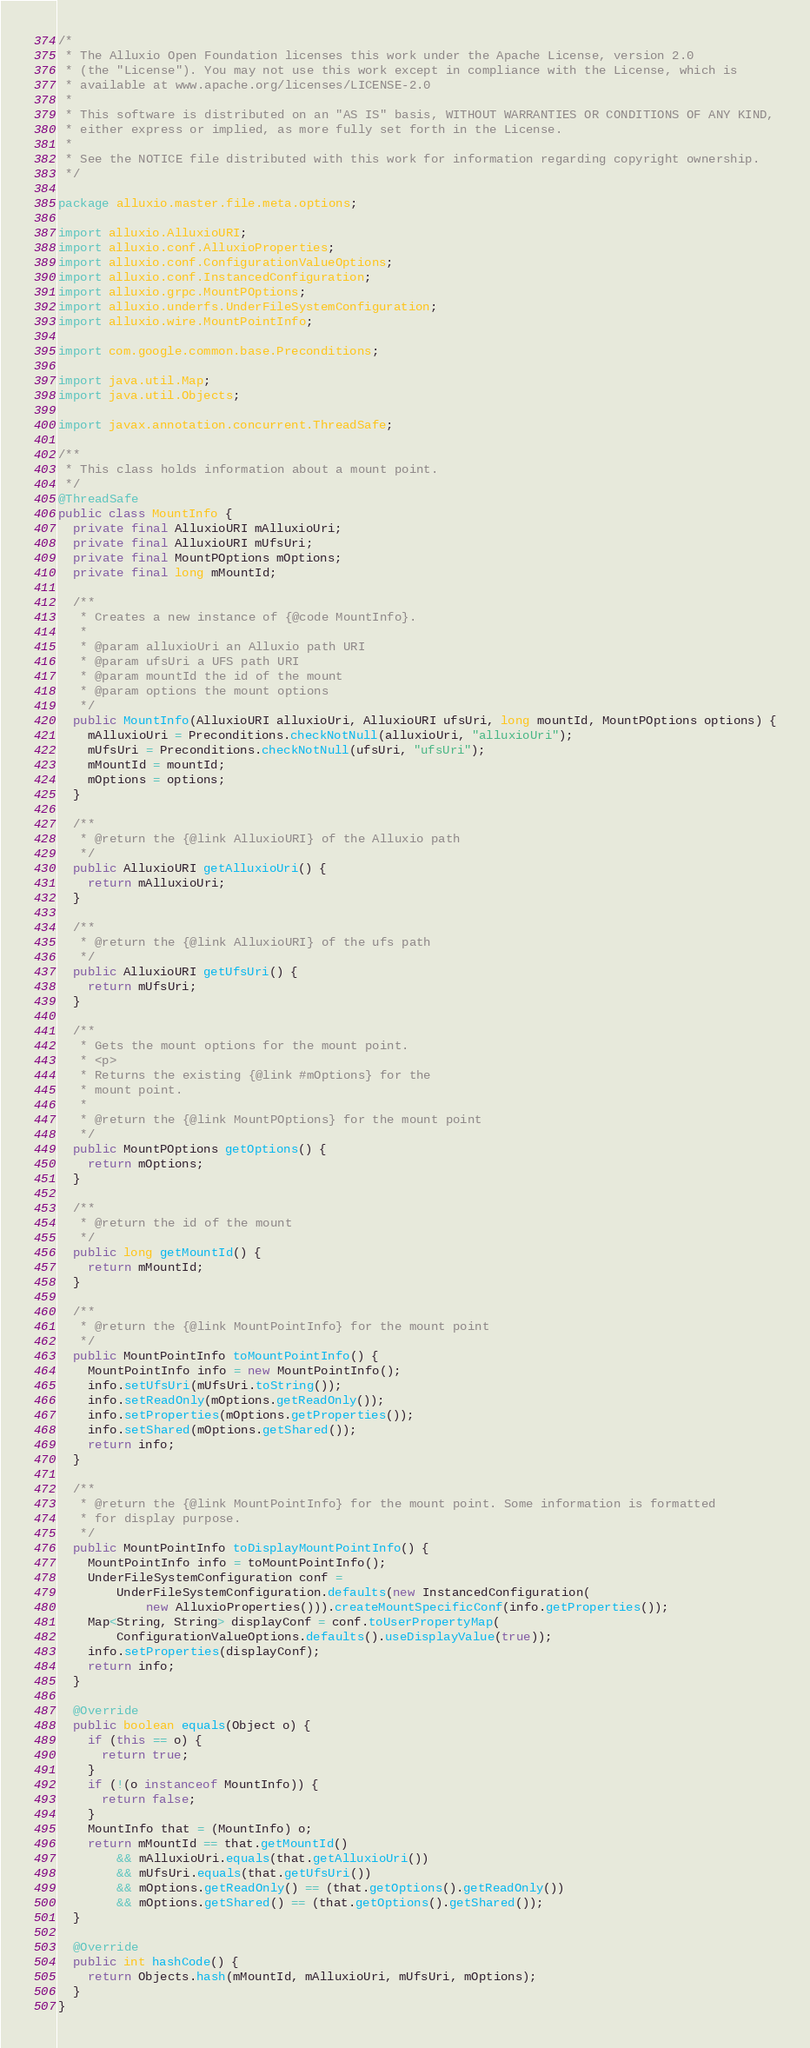<code> <loc_0><loc_0><loc_500><loc_500><_Java_>/*
 * The Alluxio Open Foundation licenses this work under the Apache License, version 2.0
 * (the "License"). You may not use this work except in compliance with the License, which is
 * available at www.apache.org/licenses/LICENSE-2.0
 *
 * This software is distributed on an "AS IS" basis, WITHOUT WARRANTIES OR CONDITIONS OF ANY KIND,
 * either express or implied, as more fully set forth in the License.
 *
 * See the NOTICE file distributed with this work for information regarding copyright ownership.
 */

package alluxio.master.file.meta.options;

import alluxio.AlluxioURI;
import alluxio.conf.AlluxioProperties;
import alluxio.conf.ConfigurationValueOptions;
import alluxio.conf.InstancedConfiguration;
import alluxio.grpc.MountPOptions;
import alluxio.underfs.UnderFileSystemConfiguration;
import alluxio.wire.MountPointInfo;

import com.google.common.base.Preconditions;

import java.util.Map;
import java.util.Objects;

import javax.annotation.concurrent.ThreadSafe;

/**
 * This class holds information about a mount point.
 */
@ThreadSafe
public class MountInfo {
  private final AlluxioURI mAlluxioUri;
  private final AlluxioURI mUfsUri;
  private final MountPOptions mOptions;
  private final long mMountId;

  /**
   * Creates a new instance of {@code MountInfo}.
   *
   * @param alluxioUri an Alluxio path URI
   * @param ufsUri a UFS path URI
   * @param mountId the id of the mount
   * @param options the mount options
   */
  public MountInfo(AlluxioURI alluxioUri, AlluxioURI ufsUri, long mountId, MountPOptions options) {
    mAlluxioUri = Preconditions.checkNotNull(alluxioUri, "alluxioUri");
    mUfsUri = Preconditions.checkNotNull(ufsUri, "ufsUri");
    mMountId = mountId;
    mOptions = options;
  }

  /**
   * @return the {@link AlluxioURI} of the Alluxio path
   */
  public AlluxioURI getAlluxioUri() {
    return mAlluxioUri;
  }

  /**
   * @return the {@link AlluxioURI} of the ufs path
   */
  public AlluxioURI getUfsUri() {
    return mUfsUri;
  }

  /**
   * Gets the mount options for the mount point.
   * <p>
   * Returns the existing {@link #mOptions} for the
   * mount point.
   *
   * @return the {@link MountPOptions} for the mount point
   */
  public MountPOptions getOptions() {
    return mOptions;
  }

  /**
   * @return the id of the mount
   */
  public long getMountId() {
    return mMountId;
  }

  /**
   * @return the {@link MountPointInfo} for the mount point
   */
  public MountPointInfo toMountPointInfo() {
    MountPointInfo info = new MountPointInfo();
    info.setUfsUri(mUfsUri.toString());
    info.setReadOnly(mOptions.getReadOnly());
    info.setProperties(mOptions.getProperties());
    info.setShared(mOptions.getShared());
    return info;
  }

  /**
   * @return the {@link MountPointInfo} for the mount point. Some information is formatted
   * for display purpose.
   */
  public MountPointInfo toDisplayMountPointInfo() {
    MountPointInfo info = toMountPointInfo();
    UnderFileSystemConfiguration conf =
        UnderFileSystemConfiguration.defaults(new InstancedConfiguration(
            new AlluxioProperties())).createMountSpecificConf(info.getProperties());
    Map<String, String> displayConf = conf.toUserPropertyMap(
        ConfigurationValueOptions.defaults().useDisplayValue(true));
    info.setProperties(displayConf);
    return info;
  }

  @Override
  public boolean equals(Object o) {
    if (this == o) {
      return true;
    }
    if (!(o instanceof MountInfo)) {
      return false;
    }
    MountInfo that = (MountInfo) o;
    return mMountId == that.getMountId()
        && mAlluxioUri.equals(that.getAlluxioUri())
        && mUfsUri.equals(that.getUfsUri())
        && mOptions.getReadOnly() == (that.getOptions().getReadOnly())
        && mOptions.getShared() == (that.getOptions().getShared());
  }

  @Override
  public int hashCode() {
    return Objects.hash(mMountId, mAlluxioUri, mUfsUri, mOptions);
  }
}
</code> 